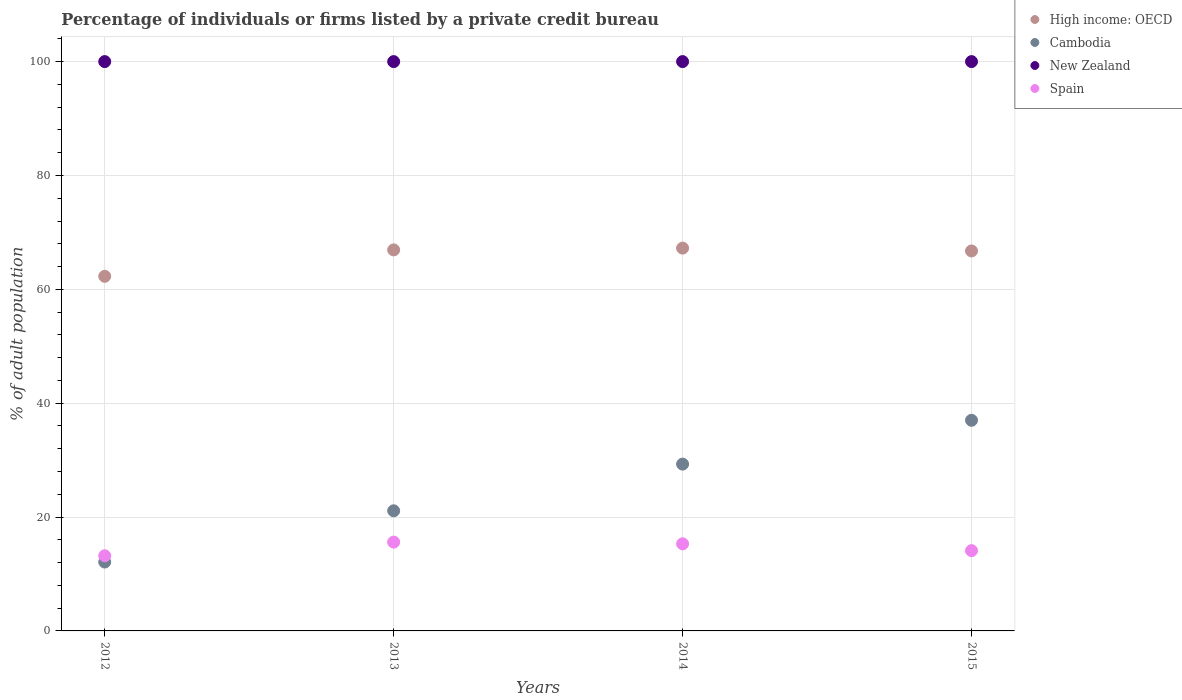How many different coloured dotlines are there?
Your response must be concise. 4. Is the number of dotlines equal to the number of legend labels?
Make the answer very short. Yes. Across all years, what is the maximum percentage of population listed by a private credit bureau in High income: OECD?
Your answer should be compact. 67.24. What is the total percentage of population listed by a private credit bureau in Spain in the graph?
Give a very brief answer. 58.2. What is the difference between the percentage of population listed by a private credit bureau in Spain in 2013 and that in 2015?
Keep it short and to the point. 1.5. What is the difference between the percentage of population listed by a private credit bureau in Cambodia in 2015 and the percentage of population listed by a private credit bureau in Spain in 2012?
Your response must be concise. 23.8. What is the average percentage of population listed by a private credit bureau in Spain per year?
Ensure brevity in your answer.  14.55. In the year 2015, what is the difference between the percentage of population listed by a private credit bureau in High income: OECD and percentage of population listed by a private credit bureau in Spain?
Make the answer very short. 52.64. In how many years, is the percentage of population listed by a private credit bureau in Spain greater than 36 %?
Your answer should be compact. 0. Is the percentage of population listed by a private credit bureau in High income: OECD in 2012 less than that in 2013?
Provide a succinct answer. Yes. What is the difference between the highest and the second highest percentage of population listed by a private credit bureau in Spain?
Ensure brevity in your answer.  0.3. In how many years, is the percentage of population listed by a private credit bureau in High income: OECD greater than the average percentage of population listed by a private credit bureau in High income: OECD taken over all years?
Give a very brief answer. 3. Are the values on the major ticks of Y-axis written in scientific E-notation?
Your answer should be very brief. No. Does the graph contain any zero values?
Your response must be concise. No. How many legend labels are there?
Keep it short and to the point. 4. How are the legend labels stacked?
Provide a short and direct response. Vertical. What is the title of the graph?
Your answer should be very brief. Percentage of individuals or firms listed by a private credit bureau. What is the label or title of the X-axis?
Offer a very short reply. Years. What is the label or title of the Y-axis?
Provide a short and direct response. % of adult population. What is the % of adult population of High income: OECD in 2012?
Give a very brief answer. 62.29. What is the % of adult population in Cambodia in 2012?
Your answer should be very brief. 12.1. What is the % of adult population of New Zealand in 2012?
Offer a terse response. 100. What is the % of adult population of Spain in 2012?
Your answer should be very brief. 13.2. What is the % of adult population in High income: OECD in 2013?
Offer a terse response. 66.92. What is the % of adult population in Cambodia in 2013?
Offer a very short reply. 21.1. What is the % of adult population in New Zealand in 2013?
Ensure brevity in your answer.  100. What is the % of adult population in High income: OECD in 2014?
Provide a succinct answer. 67.24. What is the % of adult population of Cambodia in 2014?
Offer a very short reply. 29.3. What is the % of adult population in New Zealand in 2014?
Your response must be concise. 100. What is the % of adult population of High income: OECD in 2015?
Your response must be concise. 66.74. What is the % of adult population in Spain in 2015?
Keep it short and to the point. 14.1. Across all years, what is the maximum % of adult population in High income: OECD?
Offer a terse response. 67.24. Across all years, what is the maximum % of adult population of New Zealand?
Ensure brevity in your answer.  100. Across all years, what is the maximum % of adult population in Spain?
Give a very brief answer. 15.6. Across all years, what is the minimum % of adult population in High income: OECD?
Your answer should be very brief. 62.29. Across all years, what is the minimum % of adult population in New Zealand?
Keep it short and to the point. 100. What is the total % of adult population in High income: OECD in the graph?
Offer a very short reply. 263.19. What is the total % of adult population of Cambodia in the graph?
Provide a succinct answer. 99.5. What is the total % of adult population of Spain in the graph?
Make the answer very short. 58.2. What is the difference between the % of adult population of High income: OECD in 2012 and that in 2013?
Your answer should be compact. -4.64. What is the difference between the % of adult population in Cambodia in 2012 and that in 2013?
Give a very brief answer. -9. What is the difference between the % of adult population of Spain in 2012 and that in 2013?
Provide a succinct answer. -2.4. What is the difference between the % of adult population in High income: OECD in 2012 and that in 2014?
Provide a succinct answer. -4.95. What is the difference between the % of adult population of Cambodia in 2012 and that in 2014?
Keep it short and to the point. -17.2. What is the difference between the % of adult population in New Zealand in 2012 and that in 2014?
Ensure brevity in your answer.  0. What is the difference between the % of adult population in Spain in 2012 and that in 2014?
Make the answer very short. -2.1. What is the difference between the % of adult population of High income: OECD in 2012 and that in 2015?
Make the answer very short. -4.45. What is the difference between the % of adult population in Cambodia in 2012 and that in 2015?
Offer a very short reply. -24.9. What is the difference between the % of adult population of New Zealand in 2012 and that in 2015?
Ensure brevity in your answer.  0. What is the difference between the % of adult population in High income: OECD in 2013 and that in 2014?
Offer a terse response. -0.32. What is the difference between the % of adult population of New Zealand in 2013 and that in 2014?
Make the answer very short. 0. What is the difference between the % of adult population in Spain in 2013 and that in 2014?
Provide a succinct answer. 0.3. What is the difference between the % of adult population of High income: OECD in 2013 and that in 2015?
Your answer should be very brief. 0.18. What is the difference between the % of adult population of Cambodia in 2013 and that in 2015?
Give a very brief answer. -15.9. What is the difference between the % of adult population in New Zealand in 2013 and that in 2015?
Provide a short and direct response. 0. What is the difference between the % of adult population in Spain in 2013 and that in 2015?
Ensure brevity in your answer.  1.5. What is the difference between the % of adult population in High income: OECD in 2014 and that in 2015?
Make the answer very short. 0.5. What is the difference between the % of adult population in Cambodia in 2014 and that in 2015?
Your answer should be compact. -7.7. What is the difference between the % of adult population of Spain in 2014 and that in 2015?
Make the answer very short. 1.2. What is the difference between the % of adult population of High income: OECD in 2012 and the % of adult population of Cambodia in 2013?
Your answer should be compact. 41.19. What is the difference between the % of adult population in High income: OECD in 2012 and the % of adult population in New Zealand in 2013?
Your response must be concise. -37.71. What is the difference between the % of adult population in High income: OECD in 2012 and the % of adult population in Spain in 2013?
Your response must be concise. 46.69. What is the difference between the % of adult population of Cambodia in 2012 and the % of adult population of New Zealand in 2013?
Provide a short and direct response. -87.9. What is the difference between the % of adult population of New Zealand in 2012 and the % of adult population of Spain in 2013?
Give a very brief answer. 84.4. What is the difference between the % of adult population in High income: OECD in 2012 and the % of adult population in Cambodia in 2014?
Keep it short and to the point. 32.99. What is the difference between the % of adult population in High income: OECD in 2012 and the % of adult population in New Zealand in 2014?
Provide a short and direct response. -37.71. What is the difference between the % of adult population of High income: OECD in 2012 and the % of adult population of Spain in 2014?
Your answer should be compact. 46.99. What is the difference between the % of adult population in Cambodia in 2012 and the % of adult population in New Zealand in 2014?
Offer a terse response. -87.9. What is the difference between the % of adult population of New Zealand in 2012 and the % of adult population of Spain in 2014?
Your answer should be compact. 84.7. What is the difference between the % of adult population in High income: OECD in 2012 and the % of adult population in Cambodia in 2015?
Offer a very short reply. 25.29. What is the difference between the % of adult population of High income: OECD in 2012 and the % of adult population of New Zealand in 2015?
Your answer should be compact. -37.71. What is the difference between the % of adult population of High income: OECD in 2012 and the % of adult population of Spain in 2015?
Make the answer very short. 48.19. What is the difference between the % of adult population of Cambodia in 2012 and the % of adult population of New Zealand in 2015?
Offer a terse response. -87.9. What is the difference between the % of adult population of New Zealand in 2012 and the % of adult population of Spain in 2015?
Provide a succinct answer. 85.9. What is the difference between the % of adult population of High income: OECD in 2013 and the % of adult population of Cambodia in 2014?
Provide a short and direct response. 37.62. What is the difference between the % of adult population in High income: OECD in 2013 and the % of adult population in New Zealand in 2014?
Provide a succinct answer. -33.08. What is the difference between the % of adult population in High income: OECD in 2013 and the % of adult population in Spain in 2014?
Your answer should be compact. 51.62. What is the difference between the % of adult population of Cambodia in 2013 and the % of adult population of New Zealand in 2014?
Your answer should be very brief. -78.9. What is the difference between the % of adult population of New Zealand in 2013 and the % of adult population of Spain in 2014?
Your answer should be compact. 84.7. What is the difference between the % of adult population in High income: OECD in 2013 and the % of adult population in Cambodia in 2015?
Ensure brevity in your answer.  29.93. What is the difference between the % of adult population of High income: OECD in 2013 and the % of adult population of New Zealand in 2015?
Offer a very short reply. -33.08. What is the difference between the % of adult population in High income: OECD in 2013 and the % of adult population in Spain in 2015?
Offer a very short reply. 52.83. What is the difference between the % of adult population of Cambodia in 2013 and the % of adult population of New Zealand in 2015?
Provide a succinct answer. -78.9. What is the difference between the % of adult population of Cambodia in 2013 and the % of adult population of Spain in 2015?
Provide a succinct answer. 7. What is the difference between the % of adult population in New Zealand in 2013 and the % of adult population in Spain in 2015?
Give a very brief answer. 85.9. What is the difference between the % of adult population in High income: OECD in 2014 and the % of adult population in Cambodia in 2015?
Your answer should be very brief. 30.24. What is the difference between the % of adult population of High income: OECD in 2014 and the % of adult population of New Zealand in 2015?
Your answer should be very brief. -32.76. What is the difference between the % of adult population in High income: OECD in 2014 and the % of adult population in Spain in 2015?
Offer a very short reply. 53.14. What is the difference between the % of adult population of Cambodia in 2014 and the % of adult population of New Zealand in 2015?
Offer a terse response. -70.7. What is the difference between the % of adult population of New Zealand in 2014 and the % of adult population of Spain in 2015?
Your response must be concise. 85.9. What is the average % of adult population of High income: OECD per year?
Give a very brief answer. 65.8. What is the average % of adult population of Cambodia per year?
Offer a very short reply. 24.88. What is the average % of adult population of New Zealand per year?
Provide a succinct answer. 100. What is the average % of adult population in Spain per year?
Provide a succinct answer. 14.55. In the year 2012, what is the difference between the % of adult population of High income: OECD and % of adult population of Cambodia?
Offer a very short reply. 50.19. In the year 2012, what is the difference between the % of adult population of High income: OECD and % of adult population of New Zealand?
Provide a short and direct response. -37.71. In the year 2012, what is the difference between the % of adult population in High income: OECD and % of adult population in Spain?
Your answer should be very brief. 49.09. In the year 2012, what is the difference between the % of adult population in Cambodia and % of adult population in New Zealand?
Your answer should be compact. -87.9. In the year 2012, what is the difference between the % of adult population of Cambodia and % of adult population of Spain?
Your response must be concise. -1.1. In the year 2012, what is the difference between the % of adult population of New Zealand and % of adult population of Spain?
Offer a terse response. 86.8. In the year 2013, what is the difference between the % of adult population in High income: OECD and % of adult population in Cambodia?
Ensure brevity in your answer.  45.83. In the year 2013, what is the difference between the % of adult population of High income: OECD and % of adult population of New Zealand?
Ensure brevity in your answer.  -33.08. In the year 2013, what is the difference between the % of adult population of High income: OECD and % of adult population of Spain?
Offer a very short reply. 51.33. In the year 2013, what is the difference between the % of adult population in Cambodia and % of adult population in New Zealand?
Your answer should be very brief. -78.9. In the year 2013, what is the difference between the % of adult population of New Zealand and % of adult population of Spain?
Your answer should be compact. 84.4. In the year 2014, what is the difference between the % of adult population in High income: OECD and % of adult population in Cambodia?
Your response must be concise. 37.94. In the year 2014, what is the difference between the % of adult population of High income: OECD and % of adult population of New Zealand?
Make the answer very short. -32.76. In the year 2014, what is the difference between the % of adult population of High income: OECD and % of adult population of Spain?
Provide a short and direct response. 51.94. In the year 2014, what is the difference between the % of adult population in Cambodia and % of adult population in New Zealand?
Your answer should be compact. -70.7. In the year 2014, what is the difference between the % of adult population of Cambodia and % of adult population of Spain?
Offer a terse response. 14. In the year 2014, what is the difference between the % of adult population of New Zealand and % of adult population of Spain?
Ensure brevity in your answer.  84.7. In the year 2015, what is the difference between the % of adult population in High income: OECD and % of adult population in Cambodia?
Your answer should be compact. 29.74. In the year 2015, what is the difference between the % of adult population of High income: OECD and % of adult population of New Zealand?
Offer a very short reply. -33.26. In the year 2015, what is the difference between the % of adult population in High income: OECD and % of adult population in Spain?
Your response must be concise. 52.64. In the year 2015, what is the difference between the % of adult population in Cambodia and % of adult population in New Zealand?
Give a very brief answer. -63. In the year 2015, what is the difference between the % of adult population in Cambodia and % of adult population in Spain?
Make the answer very short. 22.9. In the year 2015, what is the difference between the % of adult population in New Zealand and % of adult population in Spain?
Give a very brief answer. 85.9. What is the ratio of the % of adult population in High income: OECD in 2012 to that in 2013?
Provide a succinct answer. 0.93. What is the ratio of the % of adult population of Cambodia in 2012 to that in 2013?
Provide a short and direct response. 0.57. What is the ratio of the % of adult population of Spain in 2012 to that in 2013?
Your answer should be compact. 0.85. What is the ratio of the % of adult population of High income: OECD in 2012 to that in 2014?
Ensure brevity in your answer.  0.93. What is the ratio of the % of adult population in Cambodia in 2012 to that in 2014?
Your answer should be compact. 0.41. What is the ratio of the % of adult population of New Zealand in 2012 to that in 2014?
Make the answer very short. 1. What is the ratio of the % of adult population in Spain in 2012 to that in 2014?
Make the answer very short. 0.86. What is the ratio of the % of adult population in Cambodia in 2012 to that in 2015?
Ensure brevity in your answer.  0.33. What is the ratio of the % of adult population in Spain in 2012 to that in 2015?
Your answer should be compact. 0.94. What is the ratio of the % of adult population in Cambodia in 2013 to that in 2014?
Your answer should be very brief. 0.72. What is the ratio of the % of adult population in New Zealand in 2013 to that in 2014?
Your answer should be very brief. 1. What is the ratio of the % of adult population of Spain in 2013 to that in 2014?
Your answer should be compact. 1.02. What is the ratio of the % of adult population of Cambodia in 2013 to that in 2015?
Ensure brevity in your answer.  0.57. What is the ratio of the % of adult population of New Zealand in 2013 to that in 2015?
Your response must be concise. 1. What is the ratio of the % of adult population in Spain in 2013 to that in 2015?
Ensure brevity in your answer.  1.11. What is the ratio of the % of adult population in High income: OECD in 2014 to that in 2015?
Keep it short and to the point. 1.01. What is the ratio of the % of adult population in Cambodia in 2014 to that in 2015?
Provide a succinct answer. 0.79. What is the ratio of the % of adult population of New Zealand in 2014 to that in 2015?
Keep it short and to the point. 1. What is the ratio of the % of adult population in Spain in 2014 to that in 2015?
Provide a succinct answer. 1.09. What is the difference between the highest and the second highest % of adult population in High income: OECD?
Offer a very short reply. 0.32. What is the difference between the highest and the second highest % of adult population in New Zealand?
Your answer should be compact. 0. What is the difference between the highest and the second highest % of adult population in Spain?
Offer a very short reply. 0.3. What is the difference between the highest and the lowest % of adult population in High income: OECD?
Your answer should be compact. 4.95. What is the difference between the highest and the lowest % of adult population in Cambodia?
Make the answer very short. 24.9. What is the difference between the highest and the lowest % of adult population in New Zealand?
Make the answer very short. 0. 